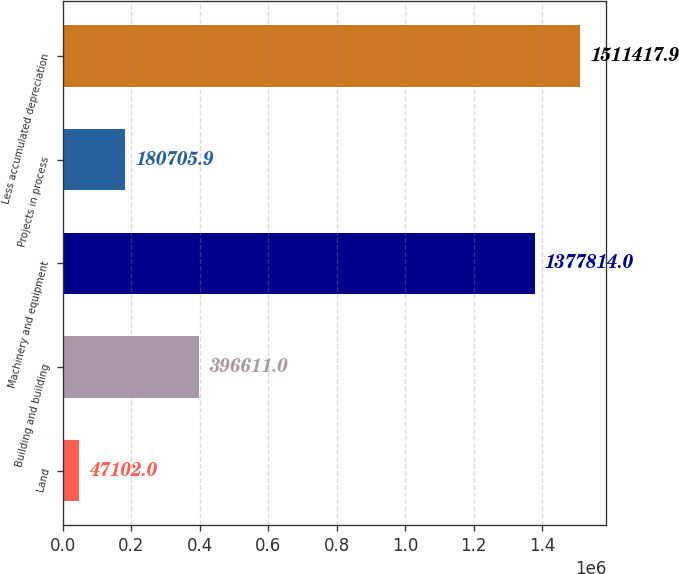Convert chart. <chart><loc_0><loc_0><loc_500><loc_500><bar_chart><fcel>Land<fcel>Building and building<fcel>Machinery and equipment<fcel>Projects in process<fcel>Less accumulated depreciation<nl><fcel>47102<fcel>396611<fcel>1.37781e+06<fcel>180706<fcel>1.51142e+06<nl></chart> 